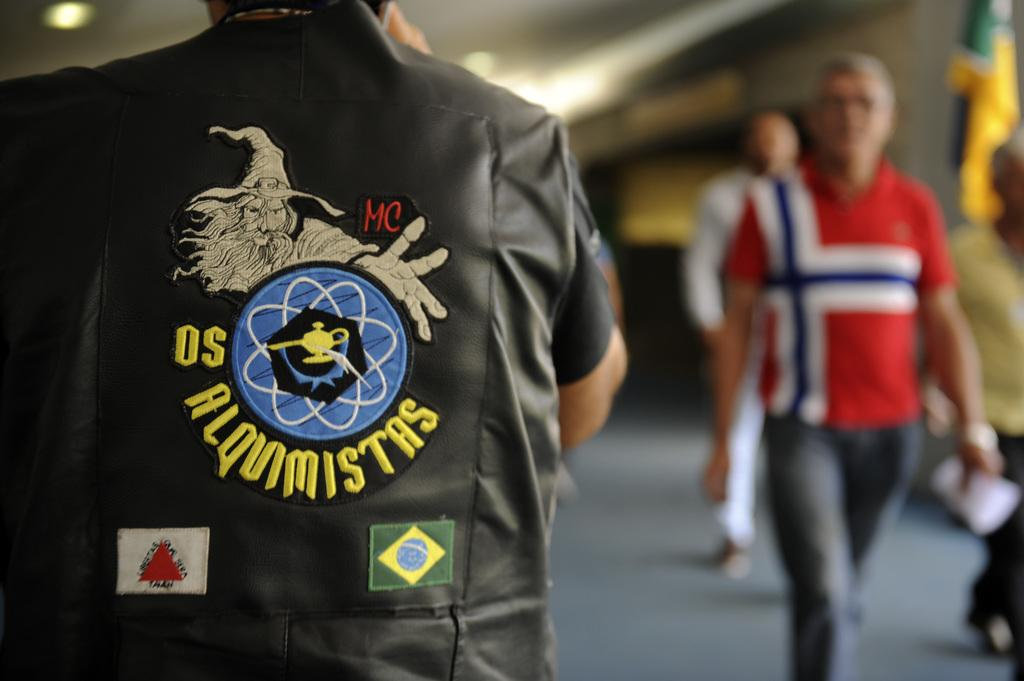<image>
Summarize the visual content of the image. a person with the word Misters on his jacket 